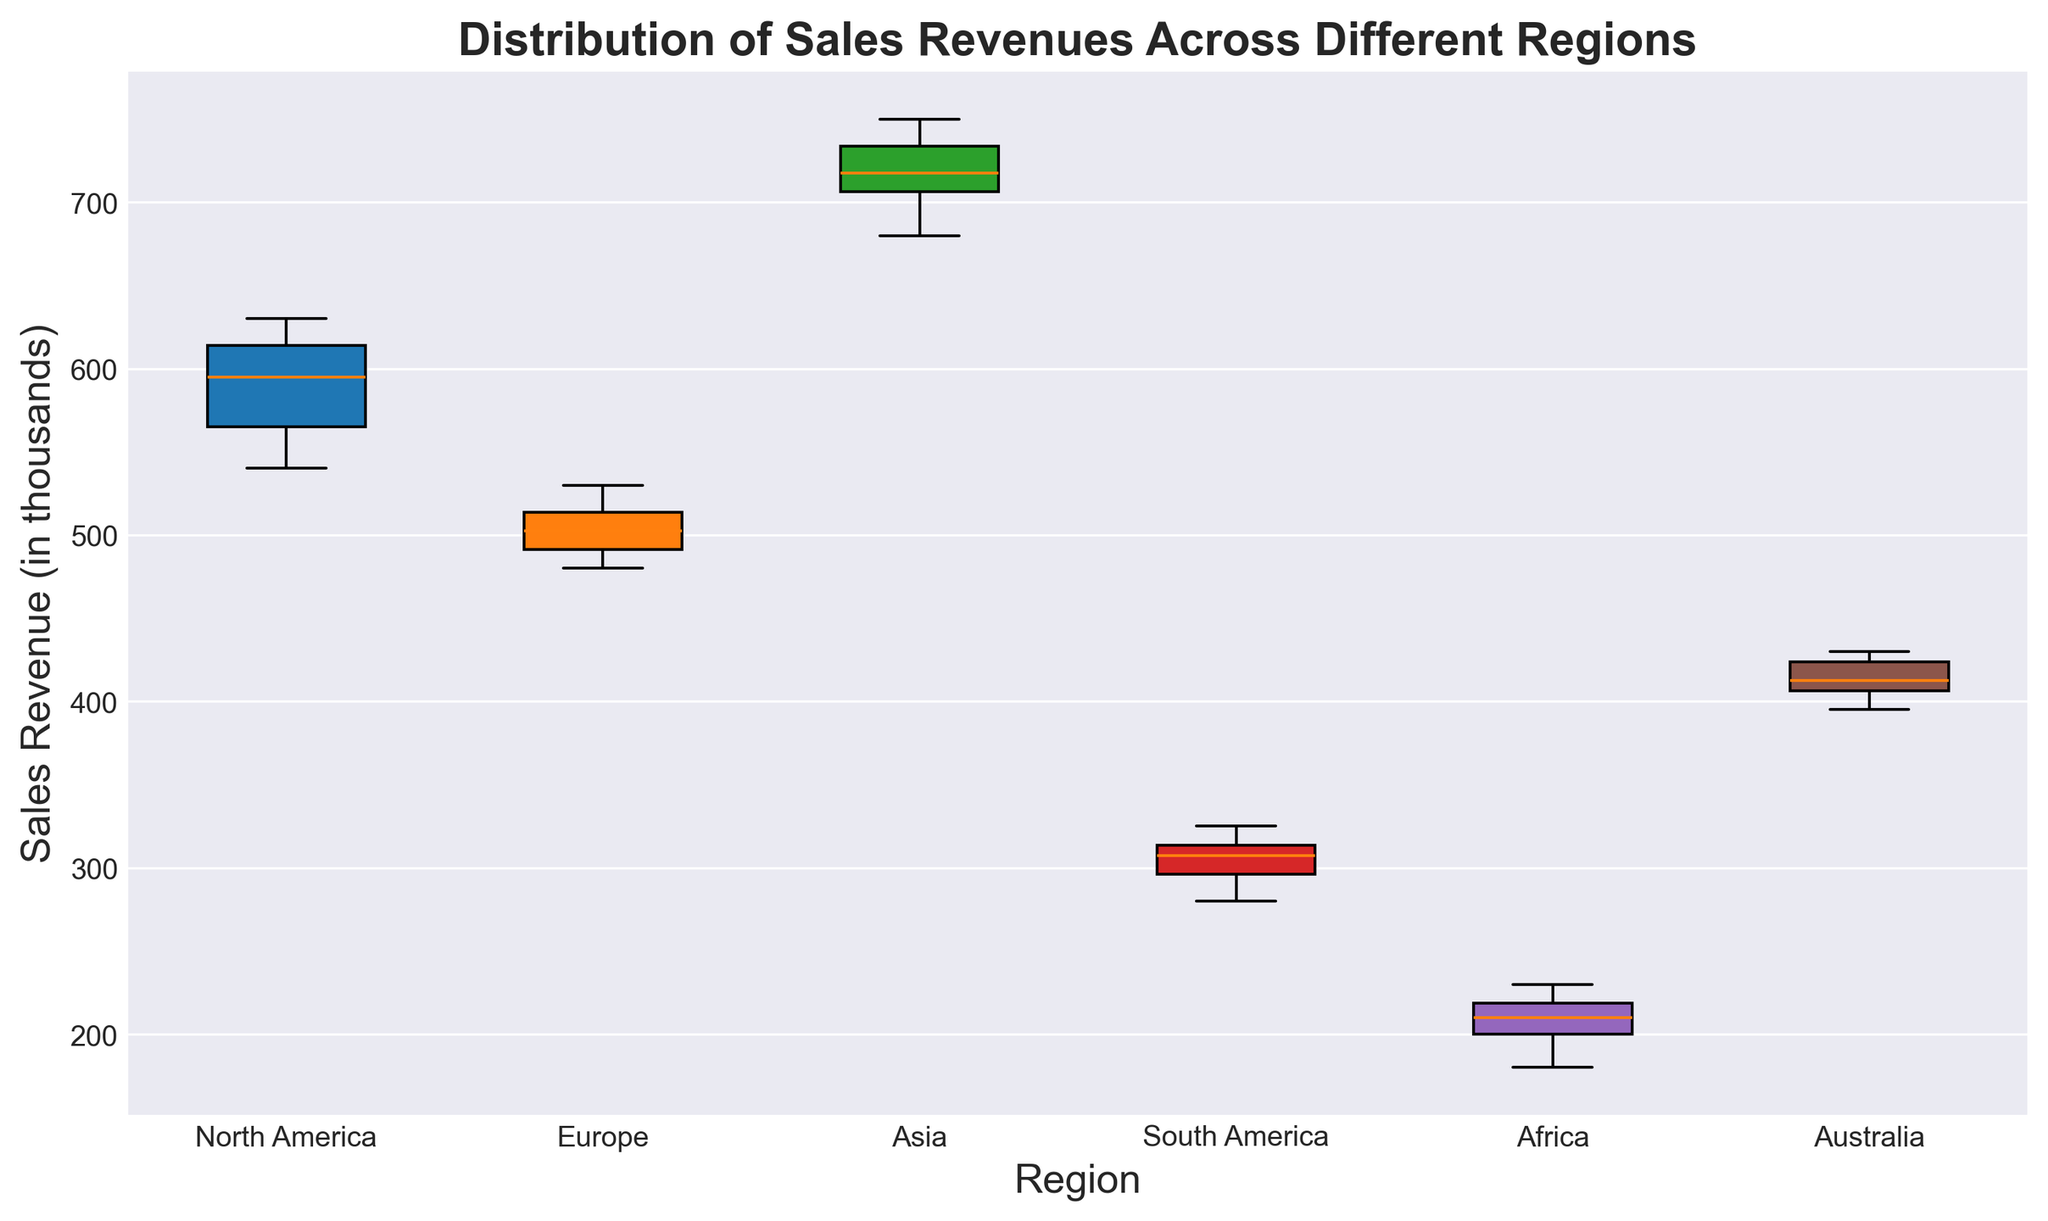What is the median sales revenue for North America? To find the median, locate the middle data point when the values are sorted. The median for North America is halfway between the 5th and 6th data values, which are 590 and 600. Together they are 1190, so divided by 2 is 595
Answer: 595 Which region has the highest median sales revenue? From the box plot, identify the line inside each box, which represents the median. The highest median line corresponds to the region above 700.
Answer: Asia Which region has the lowest median sales revenue? The lowest median sales revenue corresponds to the region whose median line is closest to the bottom of the plot. In this case, it is the region with a median around 205.
Answer: Africa Compare the interquartile ranges (IQRs) of North America and Europe. Which one is larger? The IQR is the difference between the third quartile (top of the box) and the first quartile (bottom of the box). North America's IQR spans from approximately 555 to 615, and Europe's spans from about 485 to 510, so North America's IQR is larger (60 compared to 25).
Answer: North America Which region has the widest range of sales revenues? The range is found by looking at the length of the whiskers (minimum to maximum values). The region with the widest range has its whiskers spanning the largest distance. In this case, it is the region with a range from 680 to 750.
Answer: Asia Are there any outliers visible in the data? Outliers are typically represented as individual points beyond the whiskers. Check if there are any isolated points outside the whiskers in any region.
Answer: No Which region has the second-lowest maximum sales revenue? For each box plot, find the second-highest whisker, corresponding to the second-highest max value which is between approximately 320–325.
Answer: South America How does the median sales revenue for Asia compare to that of Australia? Compare the middle lines of the box plots of Asia and Australia, where Asia's median is approximately 720 and Australia’s is approximately 410.
Answer: Asia is higher Which regions have overlapping interquartile ranges? Overlapping IQRs can be identified by examining the boxes that span similar vertical extents. Europe and Australia have overlapping ranges, as they have similar lengths and positions of their boxes.
Answer: Europe and Australia 